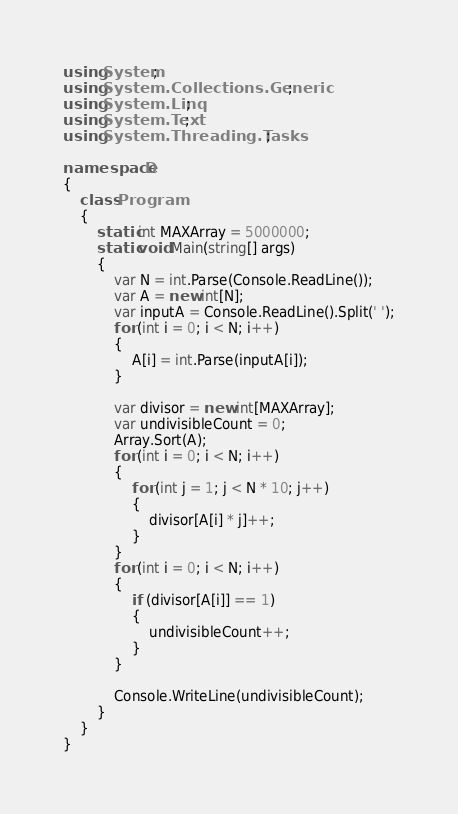<code> <loc_0><loc_0><loc_500><loc_500><_C#_>using System;
using System.Collections.Generic;
using System.Linq;
using System.Text;
using System.Threading.Tasks;

namespace D
{
    class Program
    {
        static int MAXArray = 5000000;
        static void Main(string[] args)
        {
            var N = int.Parse(Console.ReadLine());
            var A = new int[N];
            var inputA = Console.ReadLine().Split(' ');
            for (int i = 0; i < N; i++)
            {
                A[i] = int.Parse(inputA[i]);
            }

            var divisor = new int[MAXArray];
            var undivisibleCount = 0;
            Array.Sort(A);
            for (int i = 0; i < N; i++)
            {
                for (int j = 1; j < N * 10; j++)
                {
                    divisor[A[i] * j]++;
                }
            }
            for (int i = 0; i < N; i++)
            {
                if (divisor[A[i]] == 1)
                {
                    undivisibleCount++;
                }
            }

            Console.WriteLine(undivisibleCount);
        }
    }
}</code> 